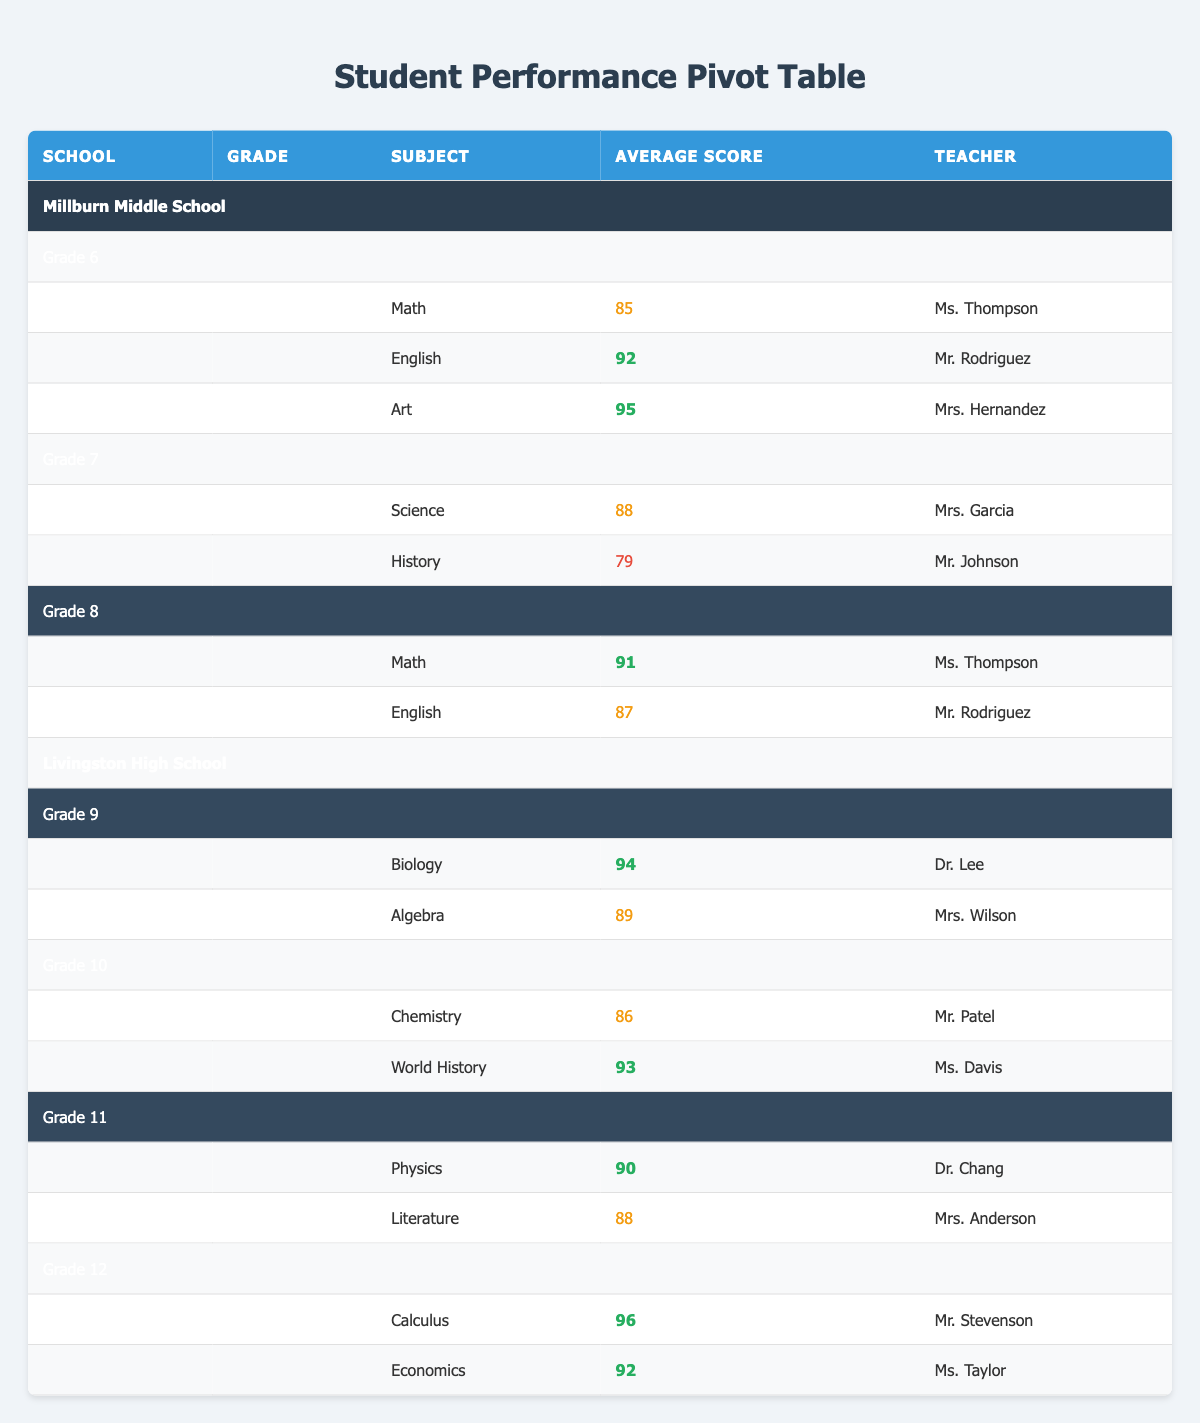What is the average score for Grade 6 students? The scores for Grade 6 students are 85 (Math), 92 (English), and 95 (Art). To find the average, we add these scores: 85 + 92 + 95 = 272. There are 3 students, so the average is 272 / 3 = 90.67.
Answer: 90.67 Which subject had the highest score in Grade 9? In Grade 9, the scores for Biology and Algebra are 94 and 89, respectively. The highest score among these is 94 (Biology), which is greater than 89.
Answer: Biology Did any student receive a score lower than 80? Yes, one student, Ethan Williams, received a score of 79 in History, which is lower than 80.
Answer: Yes What is the total number of subjects taught in Grade 10? In Grade 10, the subjects listed are Chemistry and World History. Therefore, there are 2 subjects taught.
Answer: 2 If you compare the average scores of students in Millburn Middle School and Livingston High School, which school has a higher average score? First, we calculate the average score for Millburn Middle School: (85 + 92 + 95 + 88 + 79 + 91 + 87) = 517, and there are 7 students, so the average is 517 / 7 = 73.86. Next, for Livingston High School: (94 + 89 + 86 + 93 + 90 + 88 + 96 + 92) = 728, and there are 8 students, resulting in an average of 728 / 8 = 91. So, Livingston High School has a higher average score.
Answer: Livingston High School What score did the teacher Ms. Davis' students achieve in World History? The only student taught by Ms. Davis in World History is Liam O'Connor who scored 93.
Answer: 93 In which grade level did Ms. Thompson teach, and how many subjects is she teaching? Ms. Thompson teaches Math in Grade 6 and Math in Grade 8, which means she is teaching 2 subjects overall.
Answer: 2 Which school had more subjects with scores above 90? Looking at the scores, Millburn Middle School has two subjects with scores above 90 (English and Art). Livingston High School also has four subjects with scores above 90 (Biology, World History, Physics, Calculus, and Economics). Therefore, Livingston High School has more subjects with scores above 90.
Answer: Livingston High School 